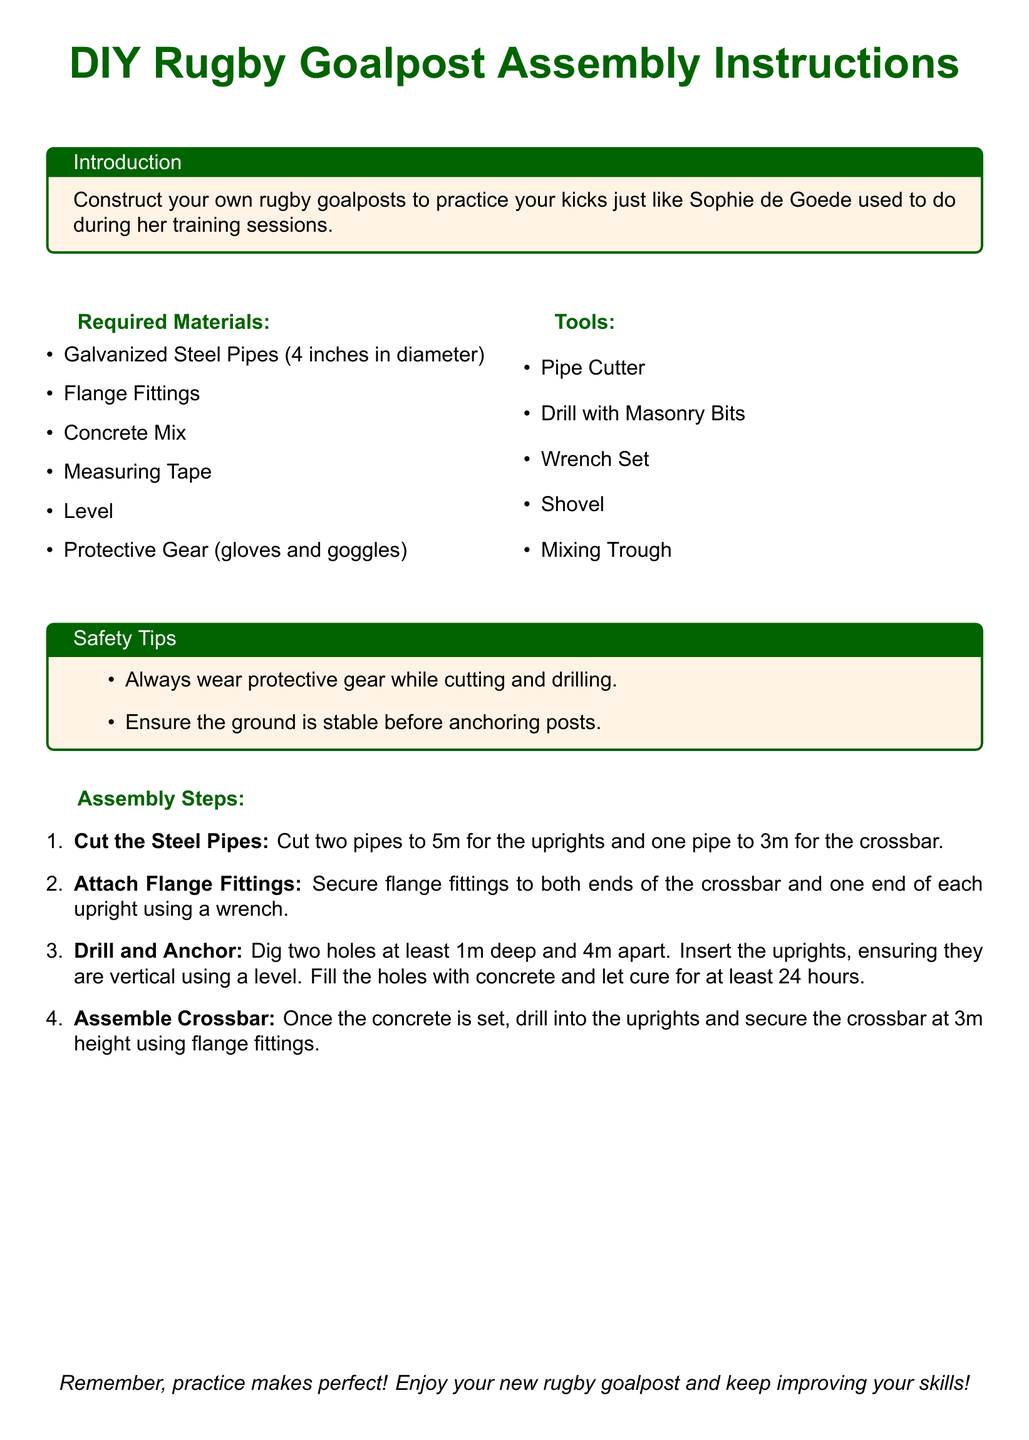What are the dimensions of the uprights? The uprights need to be cut to a length of 5 meters.
Answer: 5m What material is used for the crossbar? The crossbar is constructed from galvanized steel pipes.
Answer: Galvanized steel pipes How deep should the holes be for anchoring the posts? The document specifies that the holes should be at least 1 meter deep.
Answer: 1m What safety gear is recommended? The recommended protective gear includes gloves and goggles.
Answer: Gloves and goggles What is the height of the crossbar when assembled? The crossbar is to be secured at a height of 3 meters.
Answer: 3m How long should the concrete cure? The concrete should cure for at least 24 hours after placement.
Answer: 24 hours Which tool is used to secure the flange fittings? A wrench set is the tool mentioned for securing flange fittings.
Answer: Wrench set What is the purpose of the level in the assembly steps? The level is used to ensure that the uprights are vertical.
Answer: Ensure vertical alignment What material is needed for the concrete mix? The document specifies that a concrete mix is required for anchoring.
Answer: Concrete mix 